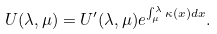Convert formula to latex. <formula><loc_0><loc_0><loc_500><loc_500>U ( \lambda , \mu ) = U ^ { \prime } ( \lambda , \mu ) e ^ { \int _ { \mu } ^ { \lambda } \kappa ( x ) d x } .</formula> 